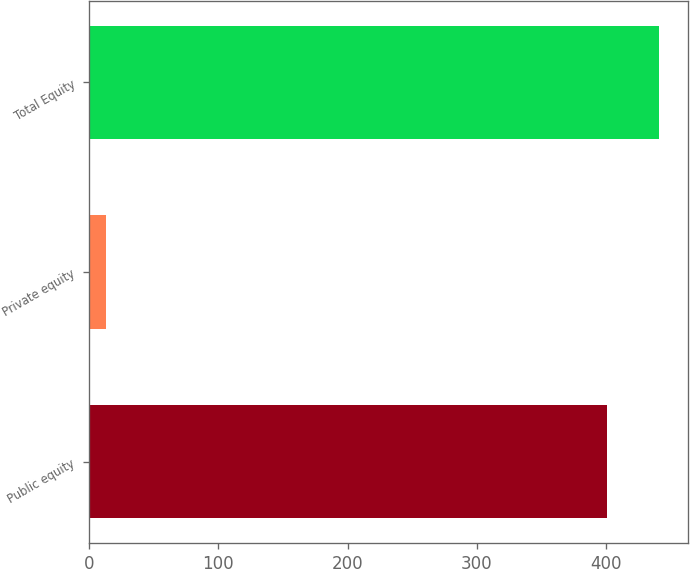Convert chart. <chart><loc_0><loc_0><loc_500><loc_500><bar_chart><fcel>Public equity<fcel>Private equity<fcel>Total Equity<nl><fcel>401<fcel>13<fcel>441.1<nl></chart> 